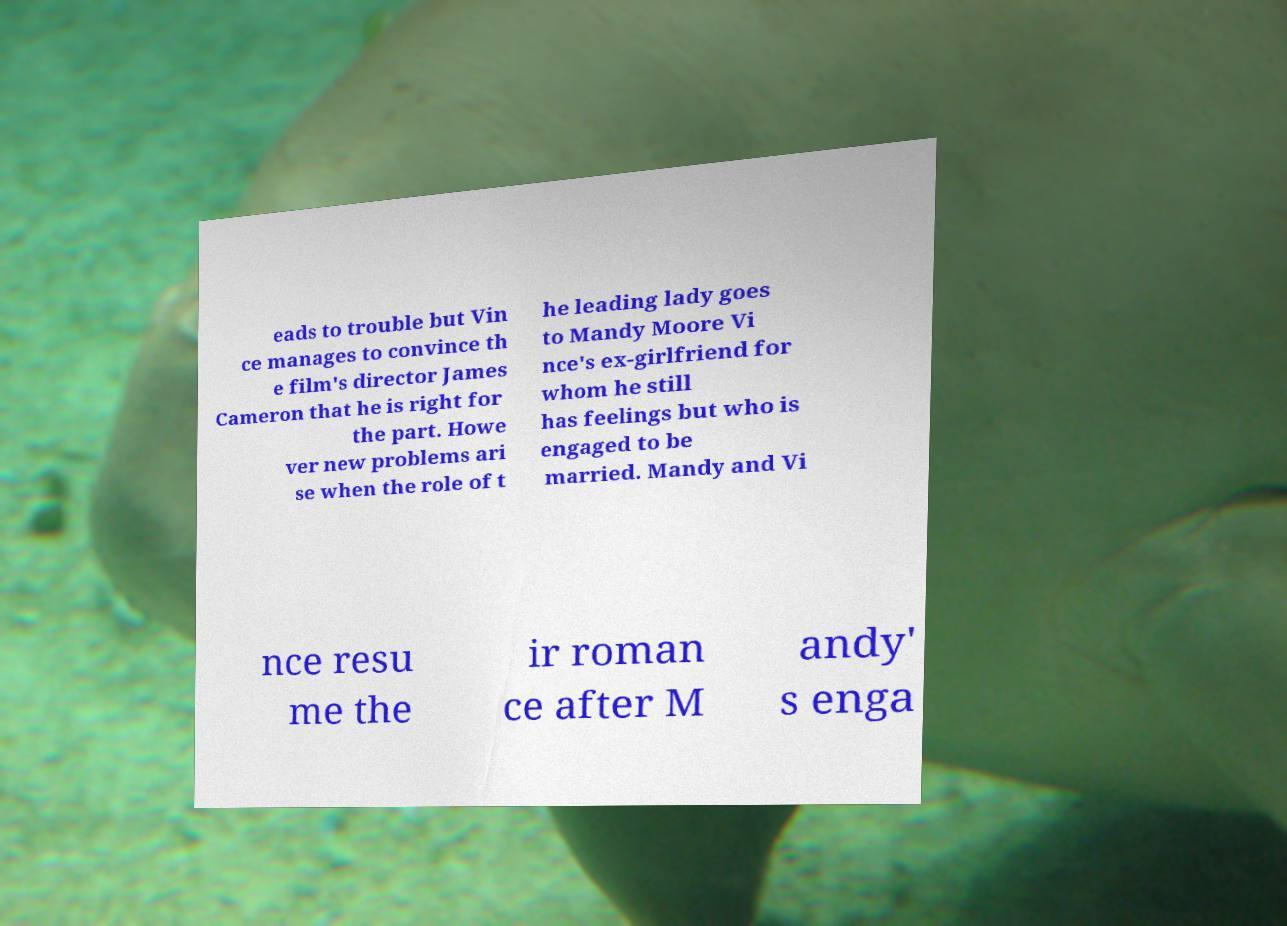Could you extract and type out the text from this image? eads to trouble but Vin ce manages to convince th e film's director James Cameron that he is right for the part. Howe ver new problems ari se when the role of t he leading lady goes to Mandy Moore Vi nce's ex-girlfriend for whom he still has feelings but who is engaged to be married. Mandy and Vi nce resu me the ir roman ce after M andy' s enga 